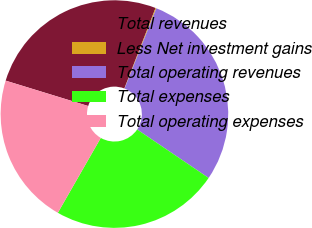<chart> <loc_0><loc_0><loc_500><loc_500><pie_chart><fcel>Total revenues<fcel>Less Net investment gains<fcel>Total operating revenues<fcel>Total expenses<fcel>Total operating expenses<nl><fcel>26.14%<fcel>0.12%<fcel>28.48%<fcel>23.8%<fcel>21.46%<nl></chart> 